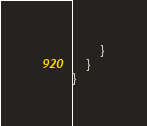<code> <loc_0><loc_0><loc_500><loc_500><_Java_>        }
    }
}
</code> 